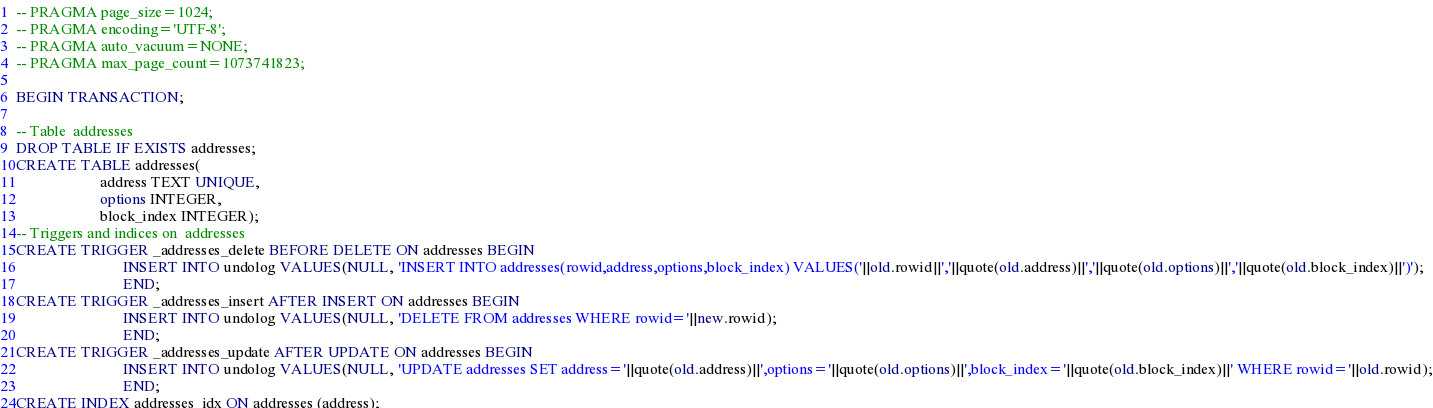<code> <loc_0><loc_0><loc_500><loc_500><_SQL_>-- PRAGMA page_size=1024;
-- PRAGMA encoding='UTF-8';
-- PRAGMA auto_vacuum=NONE;
-- PRAGMA max_page_count=1073741823;

BEGIN TRANSACTION;

-- Table  addresses
DROP TABLE IF EXISTS addresses;
CREATE TABLE addresses(
                      address TEXT UNIQUE,
                      options INTEGER,
                      block_index INTEGER);
-- Triggers and indices on  addresses
CREATE TRIGGER _addresses_delete BEFORE DELETE ON addresses BEGIN
                            INSERT INTO undolog VALUES(NULL, 'INSERT INTO addresses(rowid,address,options,block_index) VALUES('||old.rowid||','||quote(old.address)||','||quote(old.options)||','||quote(old.block_index)||')');
                            END;
CREATE TRIGGER _addresses_insert AFTER INSERT ON addresses BEGIN
                            INSERT INTO undolog VALUES(NULL, 'DELETE FROM addresses WHERE rowid='||new.rowid);
                            END;
CREATE TRIGGER _addresses_update AFTER UPDATE ON addresses BEGIN
                            INSERT INTO undolog VALUES(NULL, 'UPDATE addresses SET address='||quote(old.address)||',options='||quote(old.options)||',block_index='||quote(old.block_index)||' WHERE rowid='||old.rowid);
                            END;
CREATE INDEX addresses_idx ON addresses (address);
</code> 